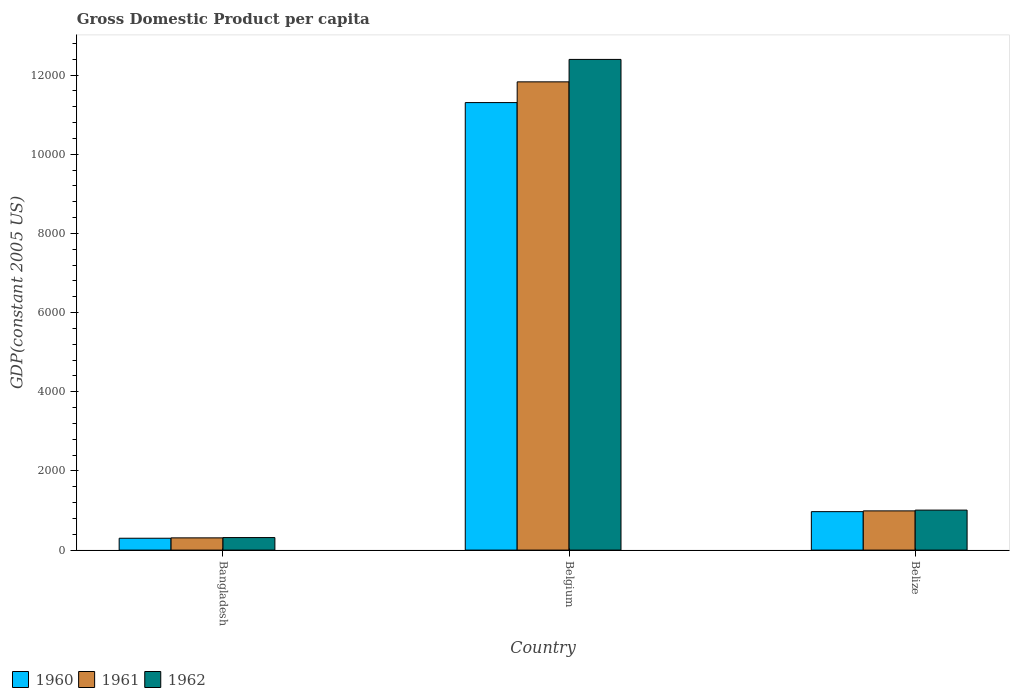Are the number of bars per tick equal to the number of legend labels?
Keep it short and to the point. Yes. In how many cases, is the number of bars for a given country not equal to the number of legend labels?
Keep it short and to the point. 0. What is the GDP per capita in 1961 in Belgium?
Your answer should be compact. 1.18e+04. Across all countries, what is the maximum GDP per capita in 1962?
Offer a terse response. 1.24e+04. Across all countries, what is the minimum GDP per capita in 1961?
Offer a terse response. 308.96. In which country was the GDP per capita in 1961 minimum?
Your response must be concise. Bangladesh. What is the total GDP per capita in 1962 in the graph?
Your answer should be compact. 1.37e+04. What is the difference between the GDP per capita in 1960 in Bangladesh and that in Belize?
Provide a succinct answer. -671.72. What is the difference between the GDP per capita in 1961 in Belize and the GDP per capita in 1962 in Belgium?
Give a very brief answer. -1.14e+04. What is the average GDP per capita in 1962 per country?
Make the answer very short. 4574.09. What is the difference between the GDP per capita of/in 1961 and GDP per capita of/in 1962 in Belize?
Your answer should be very brief. -19.79. In how many countries, is the GDP per capita in 1960 greater than 6800 US$?
Provide a succinct answer. 1. What is the ratio of the GDP per capita in 1962 in Bangladesh to that in Belize?
Your response must be concise. 0.31. What is the difference between the highest and the second highest GDP per capita in 1962?
Offer a very short reply. -1.14e+04. What is the difference between the highest and the lowest GDP per capita in 1961?
Make the answer very short. 1.15e+04. In how many countries, is the GDP per capita in 1961 greater than the average GDP per capita in 1961 taken over all countries?
Ensure brevity in your answer.  1. How many bars are there?
Provide a short and direct response. 9. How many countries are there in the graph?
Offer a terse response. 3. How many legend labels are there?
Ensure brevity in your answer.  3. What is the title of the graph?
Provide a short and direct response. Gross Domestic Product per capita. What is the label or title of the X-axis?
Give a very brief answer. Country. What is the label or title of the Y-axis?
Provide a short and direct response. GDP(constant 2005 US). What is the GDP(constant 2005 US) in 1960 in Bangladesh?
Make the answer very short. 299.73. What is the GDP(constant 2005 US) in 1961 in Bangladesh?
Offer a terse response. 308.96. What is the GDP(constant 2005 US) in 1962 in Bangladesh?
Keep it short and to the point. 316.63. What is the GDP(constant 2005 US) in 1960 in Belgium?
Provide a short and direct response. 1.13e+04. What is the GDP(constant 2005 US) of 1961 in Belgium?
Ensure brevity in your answer.  1.18e+04. What is the GDP(constant 2005 US) of 1962 in Belgium?
Make the answer very short. 1.24e+04. What is the GDP(constant 2005 US) of 1960 in Belize?
Provide a succinct answer. 971.44. What is the GDP(constant 2005 US) of 1961 in Belize?
Ensure brevity in your answer.  990.64. What is the GDP(constant 2005 US) in 1962 in Belize?
Your answer should be very brief. 1010.43. Across all countries, what is the maximum GDP(constant 2005 US) of 1960?
Make the answer very short. 1.13e+04. Across all countries, what is the maximum GDP(constant 2005 US) of 1961?
Ensure brevity in your answer.  1.18e+04. Across all countries, what is the maximum GDP(constant 2005 US) of 1962?
Your answer should be very brief. 1.24e+04. Across all countries, what is the minimum GDP(constant 2005 US) in 1960?
Offer a terse response. 299.73. Across all countries, what is the minimum GDP(constant 2005 US) of 1961?
Ensure brevity in your answer.  308.96. Across all countries, what is the minimum GDP(constant 2005 US) of 1962?
Ensure brevity in your answer.  316.63. What is the total GDP(constant 2005 US) in 1960 in the graph?
Provide a short and direct response. 1.26e+04. What is the total GDP(constant 2005 US) in 1961 in the graph?
Offer a terse response. 1.31e+04. What is the total GDP(constant 2005 US) of 1962 in the graph?
Ensure brevity in your answer.  1.37e+04. What is the difference between the GDP(constant 2005 US) in 1960 in Bangladesh and that in Belgium?
Your answer should be compact. -1.10e+04. What is the difference between the GDP(constant 2005 US) in 1961 in Bangladesh and that in Belgium?
Your answer should be compact. -1.15e+04. What is the difference between the GDP(constant 2005 US) of 1962 in Bangladesh and that in Belgium?
Your response must be concise. -1.21e+04. What is the difference between the GDP(constant 2005 US) of 1960 in Bangladesh and that in Belize?
Your answer should be very brief. -671.72. What is the difference between the GDP(constant 2005 US) in 1961 in Bangladesh and that in Belize?
Keep it short and to the point. -681.68. What is the difference between the GDP(constant 2005 US) of 1962 in Bangladesh and that in Belize?
Your response must be concise. -693.8. What is the difference between the GDP(constant 2005 US) in 1960 in Belgium and that in Belize?
Offer a terse response. 1.03e+04. What is the difference between the GDP(constant 2005 US) in 1961 in Belgium and that in Belize?
Ensure brevity in your answer.  1.08e+04. What is the difference between the GDP(constant 2005 US) of 1962 in Belgium and that in Belize?
Give a very brief answer. 1.14e+04. What is the difference between the GDP(constant 2005 US) of 1960 in Bangladesh and the GDP(constant 2005 US) of 1961 in Belgium?
Offer a terse response. -1.15e+04. What is the difference between the GDP(constant 2005 US) of 1960 in Bangladesh and the GDP(constant 2005 US) of 1962 in Belgium?
Your response must be concise. -1.21e+04. What is the difference between the GDP(constant 2005 US) in 1961 in Bangladesh and the GDP(constant 2005 US) in 1962 in Belgium?
Keep it short and to the point. -1.21e+04. What is the difference between the GDP(constant 2005 US) in 1960 in Bangladesh and the GDP(constant 2005 US) in 1961 in Belize?
Your answer should be very brief. -690.91. What is the difference between the GDP(constant 2005 US) of 1960 in Bangladesh and the GDP(constant 2005 US) of 1962 in Belize?
Keep it short and to the point. -710.7. What is the difference between the GDP(constant 2005 US) of 1961 in Bangladesh and the GDP(constant 2005 US) of 1962 in Belize?
Your answer should be compact. -701.47. What is the difference between the GDP(constant 2005 US) of 1960 in Belgium and the GDP(constant 2005 US) of 1961 in Belize?
Offer a very short reply. 1.03e+04. What is the difference between the GDP(constant 2005 US) of 1960 in Belgium and the GDP(constant 2005 US) of 1962 in Belize?
Provide a succinct answer. 1.03e+04. What is the difference between the GDP(constant 2005 US) of 1961 in Belgium and the GDP(constant 2005 US) of 1962 in Belize?
Keep it short and to the point. 1.08e+04. What is the average GDP(constant 2005 US) of 1960 per country?
Make the answer very short. 4191.97. What is the average GDP(constant 2005 US) of 1961 per country?
Give a very brief answer. 4375.92. What is the average GDP(constant 2005 US) of 1962 per country?
Keep it short and to the point. 4574.09. What is the difference between the GDP(constant 2005 US) of 1960 and GDP(constant 2005 US) of 1961 in Bangladesh?
Provide a succinct answer. -9.23. What is the difference between the GDP(constant 2005 US) of 1960 and GDP(constant 2005 US) of 1962 in Bangladesh?
Ensure brevity in your answer.  -16.9. What is the difference between the GDP(constant 2005 US) of 1961 and GDP(constant 2005 US) of 1962 in Bangladesh?
Provide a succinct answer. -7.67. What is the difference between the GDP(constant 2005 US) in 1960 and GDP(constant 2005 US) in 1961 in Belgium?
Offer a terse response. -523.44. What is the difference between the GDP(constant 2005 US) of 1960 and GDP(constant 2005 US) of 1962 in Belgium?
Your answer should be very brief. -1090.48. What is the difference between the GDP(constant 2005 US) in 1961 and GDP(constant 2005 US) in 1962 in Belgium?
Provide a short and direct response. -567.05. What is the difference between the GDP(constant 2005 US) in 1960 and GDP(constant 2005 US) in 1961 in Belize?
Offer a terse response. -19.2. What is the difference between the GDP(constant 2005 US) in 1960 and GDP(constant 2005 US) in 1962 in Belize?
Your response must be concise. -38.98. What is the difference between the GDP(constant 2005 US) in 1961 and GDP(constant 2005 US) in 1962 in Belize?
Make the answer very short. -19.79. What is the ratio of the GDP(constant 2005 US) in 1960 in Bangladesh to that in Belgium?
Your answer should be very brief. 0.03. What is the ratio of the GDP(constant 2005 US) in 1961 in Bangladesh to that in Belgium?
Ensure brevity in your answer.  0.03. What is the ratio of the GDP(constant 2005 US) in 1962 in Bangladesh to that in Belgium?
Keep it short and to the point. 0.03. What is the ratio of the GDP(constant 2005 US) of 1960 in Bangladesh to that in Belize?
Keep it short and to the point. 0.31. What is the ratio of the GDP(constant 2005 US) in 1961 in Bangladesh to that in Belize?
Provide a short and direct response. 0.31. What is the ratio of the GDP(constant 2005 US) in 1962 in Bangladesh to that in Belize?
Keep it short and to the point. 0.31. What is the ratio of the GDP(constant 2005 US) of 1960 in Belgium to that in Belize?
Your response must be concise. 11.64. What is the ratio of the GDP(constant 2005 US) of 1961 in Belgium to that in Belize?
Your answer should be compact. 11.94. What is the ratio of the GDP(constant 2005 US) of 1962 in Belgium to that in Belize?
Offer a very short reply. 12.27. What is the difference between the highest and the second highest GDP(constant 2005 US) in 1960?
Provide a succinct answer. 1.03e+04. What is the difference between the highest and the second highest GDP(constant 2005 US) of 1961?
Ensure brevity in your answer.  1.08e+04. What is the difference between the highest and the second highest GDP(constant 2005 US) in 1962?
Ensure brevity in your answer.  1.14e+04. What is the difference between the highest and the lowest GDP(constant 2005 US) of 1960?
Your response must be concise. 1.10e+04. What is the difference between the highest and the lowest GDP(constant 2005 US) of 1961?
Your answer should be compact. 1.15e+04. What is the difference between the highest and the lowest GDP(constant 2005 US) of 1962?
Keep it short and to the point. 1.21e+04. 